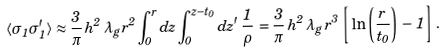Convert formula to latex. <formula><loc_0><loc_0><loc_500><loc_500>\langle \sigma _ { 1 } \sigma ^ { \prime } _ { 1 } \rangle \approx \frac { 3 } { \pi } \, h ^ { 2 } \, \lambda _ { g } \, r ^ { 2 } \int _ { 0 } ^ { r } d z \int _ { 0 } ^ { z - t _ { 0 } } d z ^ { \prime } \, \frac { 1 } { \rho } \, = \frac { 3 } { \pi } \, h ^ { 2 } \, \lambda _ { g } \, r ^ { 3 } \, \left [ \, \ln \left ( \frac { r } { t _ { 0 } } \right ) \, - \, 1 \right ] \, .</formula> 